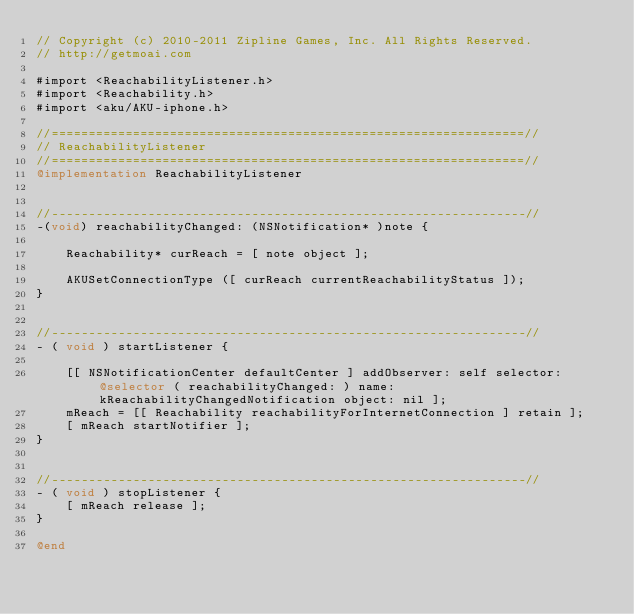Convert code to text. <code><loc_0><loc_0><loc_500><loc_500><_ObjectiveC_>// Copyright (c) 2010-2011 Zipline Games, Inc. All Rights Reserved.
// http://getmoai.com

#import <ReachabilityListener.h>
#import <Reachability.h>
#import <aku/AKU-iphone.h>

//================================================================//
// ReachabilityListener
//================================================================//
@implementation ReachabilityListener


//----------------------------------------------------------------//
-(void) reachabilityChanged: (NSNotification* )note {

	Reachability* curReach = [ note object ];
	
    AKUSetConnectionType ([ curReach currentReachabilityStatus ]);
}


//----------------------------------------------------------------//
- ( void ) startListener {

	[[ NSNotificationCenter defaultCenter ] addObserver: self selector: @selector ( reachabilityChanged: ) name: kReachabilityChangedNotification object: nil ];
	mReach = [[ Reachability reachabilityForInternetConnection ] retain ];
	[ mReach startNotifier ];
}


//----------------------------------------------------------------//
- ( void ) stopListener {	
	[ mReach release ];
}

@end
</code> 